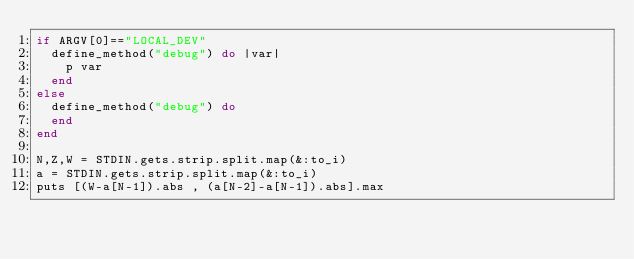<code> <loc_0><loc_0><loc_500><loc_500><_Ruby_>if ARGV[0]=="LOCAL_DEV"
  define_method("debug") do |var|
    p var
  end
else
  define_method("debug") do
  end
end

N,Z,W = STDIN.gets.strip.split.map(&:to_i)
a = STDIN.gets.strip.split.map(&:to_i)
puts [(W-a[N-1]).abs , (a[N-2]-a[N-1]).abs].max
</code> 